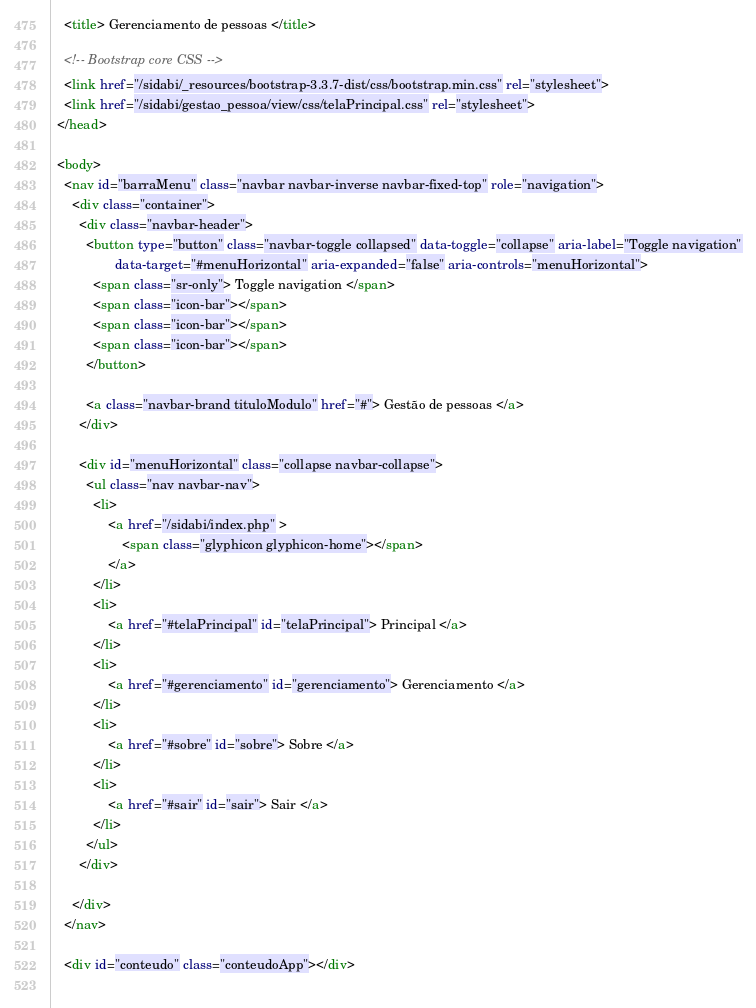<code> <loc_0><loc_0><loc_500><loc_500><_HTML_>
    <title> Gerenciamento de pessoas </title>

    <!-- Bootstrap core CSS -->
    <link href="/sidabi/_resources/bootstrap-3.3.7-dist/css/bootstrap.min.css" rel="stylesheet">
	<link href="/sidabi/gestao_pessoa/view/css/telaPrincipal.css" rel="stylesheet">
  </head>

  <body>
    <nav id="barraMenu" class="navbar navbar-inverse navbar-fixed-top" role="navigation">
      <div class="container">
        <div class="navbar-header">
          <button type="button" class="navbar-toggle collapsed" data-toggle="collapse" aria-label="Toggle navigation"
                  data-target="#menuHorizontal" aria-expanded="false" aria-controls="menuHorizontal">
            <span class="sr-only"> Toggle navigation </span>
            <span class="icon-bar"></span>
            <span class="icon-bar"></span>
            <span class="icon-bar"></span>
          </button>
          
          <a class="navbar-brand tituloModulo" href="#"> Gestão de pessoas </a>
        </div>

        <div id="menuHorizontal" class="collapse navbar-collapse">
          <ul class="nav navbar-nav">
            <li>
                <a href="/sidabi/index.php" >
                    <span class="glyphicon glyphicon-home"></span>
                </a>
            </li>
            <li>
                <a href="#telaPrincipal" id="telaPrincipal"> Principal </a>
            </li>
            <li>
                <a href="#gerenciamento" id="gerenciamento"> Gerenciamento </a>
            </li>
            <li>
                <a href="#sobre" id="sobre"> Sobre </a>
            </li>
            <li>
                <a href="#sair" id="sair"> Sair </a>
            </li>
          </ul>
        </div>
        
      </div>
    </nav>

    <div id="conteudo" class="conteudoApp"></div>
	</code> 